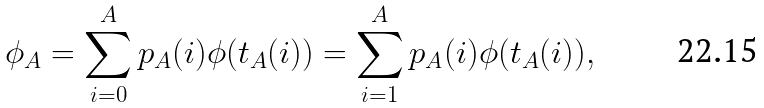<formula> <loc_0><loc_0><loc_500><loc_500>\phi _ { A } = \sum _ { i = 0 } ^ { A } p _ { A } ( i ) \phi ( t _ { A } ( i ) ) = \sum _ { i = 1 } ^ { A } p _ { A } ( i ) \phi ( t _ { A } ( i ) ) ,</formula> 